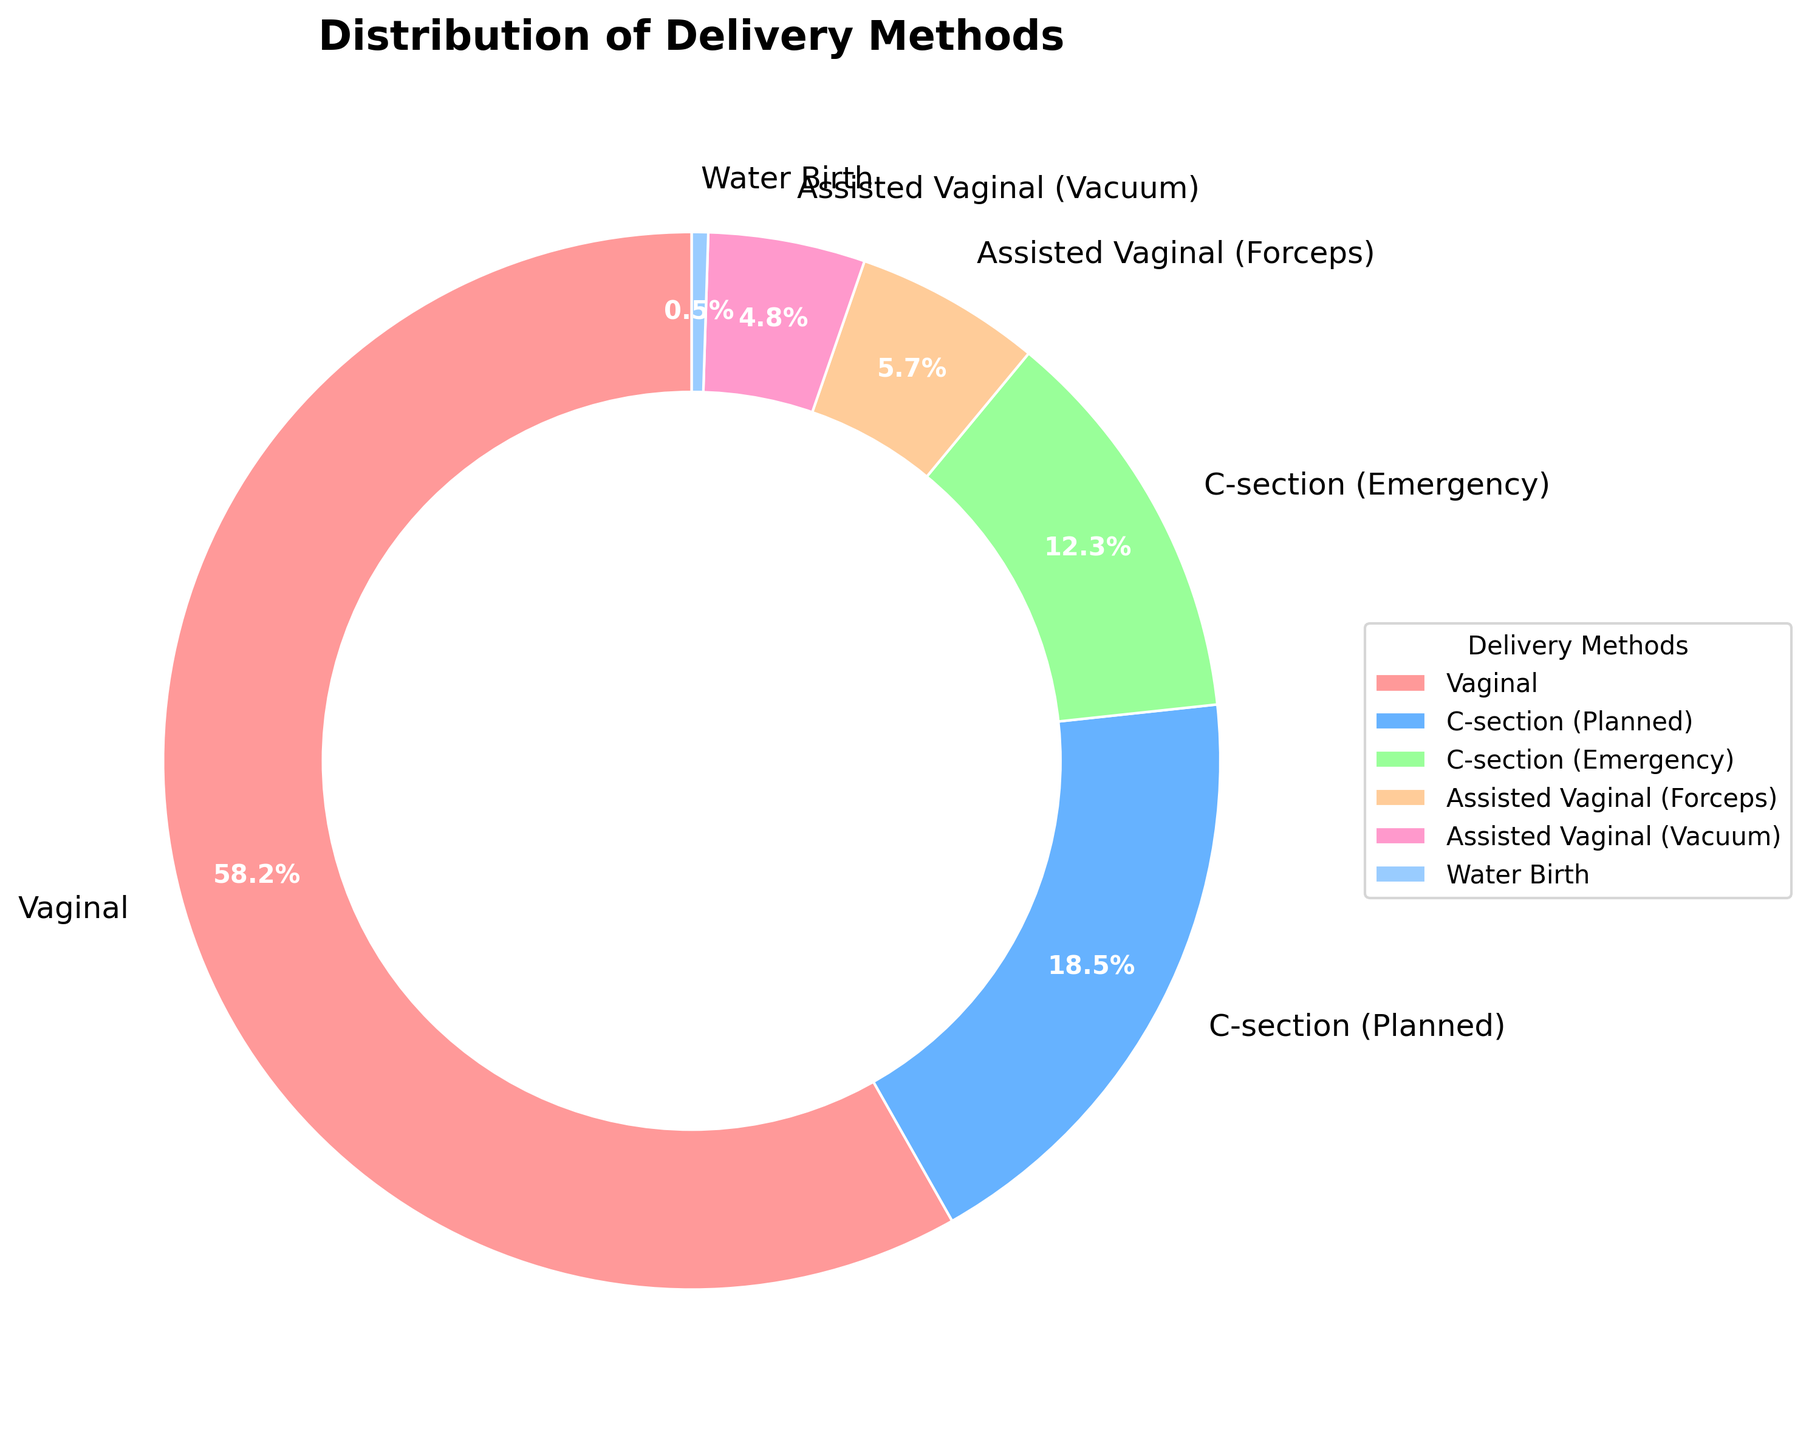Which delivery method has the highest percentage? By observing the figure, the sector with the largest slice indicates the delivery method with the highest percentage. The "Vaginal" method has the largest slice.
Answer: Vaginal What is the total percentage of deliveries done through C-section (both planned and emergency)? According to the figure, the planned C-section holds 18.5% and the emergency C-section holds 12.3%. Adding these two percentages gives us 18.5 + 12.3 = 30.8%.
Answer: 30.8% Which delivery method is the least common? The smallest slice on the pie chart represents the least common delivery method. In this case, "Water Birth" has the smallest slice with 0.5%.
Answer: Water Birth How does the percentage of assisted vaginal deliveries (Forceps and Vacuum combined) compare to C-section deliveries (Planned and Emergency combined)? The combined percentage for assisted vaginal deliveries is 5.7% (Forceps) + 4.8% (Vacuum) = 10.5%. The combined percentage for C-sections is 18.5% (Planned) + 12.3% (Emergency) = 30.8%. Comparatively, the percentage of C-section deliveries is higher than that of assisted vaginal deliveries.
Answer: C-section is higher What is the difference in percentage between Vaginal deliveries and Emergency C-section deliveries? The percentage for Vaginal deliveries is 58.2%, and for Emergency C-section deliveries, it is 12.3%. Subtracting these gives us 58.2 - 12.3 = 45.9%.
Answer: 45.9% What percentage of deliveries were not vaginal (excluding Vaginal, Assisted Vaginal, and Water Birth)? Summing up the percentages of non-vaginal deliveries: 18.5% (Planned C-section) + 12.3% (Emergency C-section) = 30.8%. Excluding water birth since it is also vaginal, so the result is 30.8%.
Answer: 30.8% Which has a higher percentage, assisted vaginal (Forceps) deliveries or assisted vaginal (Vacuum) deliveries? Observing the figure, Assisted Vaginal (Forceps) deliveries have a percentage of 5.7%, whereas Assisted Vaginal (Vacuum) deliveries have 4.8%. Thus, the Forceps method has a higher percentage than the Vacuum method.
Answer: Forceps What percent of deliveries are vaginal combined with assisted vaginal methods? The data shows Vaginal deliveries at 58.2%, Forceps-assisted at 5.7%, and Vacuum-assisted at 4.8%. Adding these percentages gives: 58.2 + 5.7 + 4.8 = 68.7%.
Answer: 68.7% Are there more planned C-section deliveries or assisted vaginal deliveries (Forceps and Vacuum combined)? Comparing the 18.5% for Planned C-sections with the combined 5.7% (Forceps) + 4.8% (Vacuum) = 10.5% for assisted vaginal deliveries, we can see that Planned C-sections are more common.
Answer: Planned C-sections are more common 